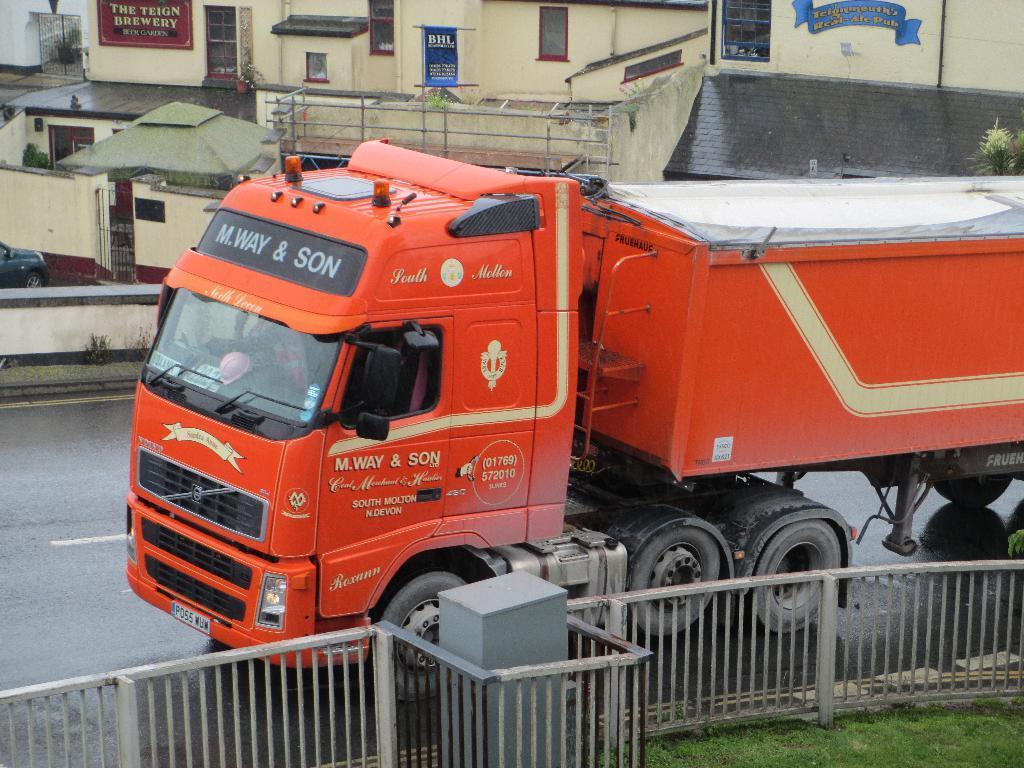Can you describe this image briefly? In the picture we can see a truck on the road and beside it we can see the railing and a grass surface and on the other side of the road we can see some buildings with windows. 